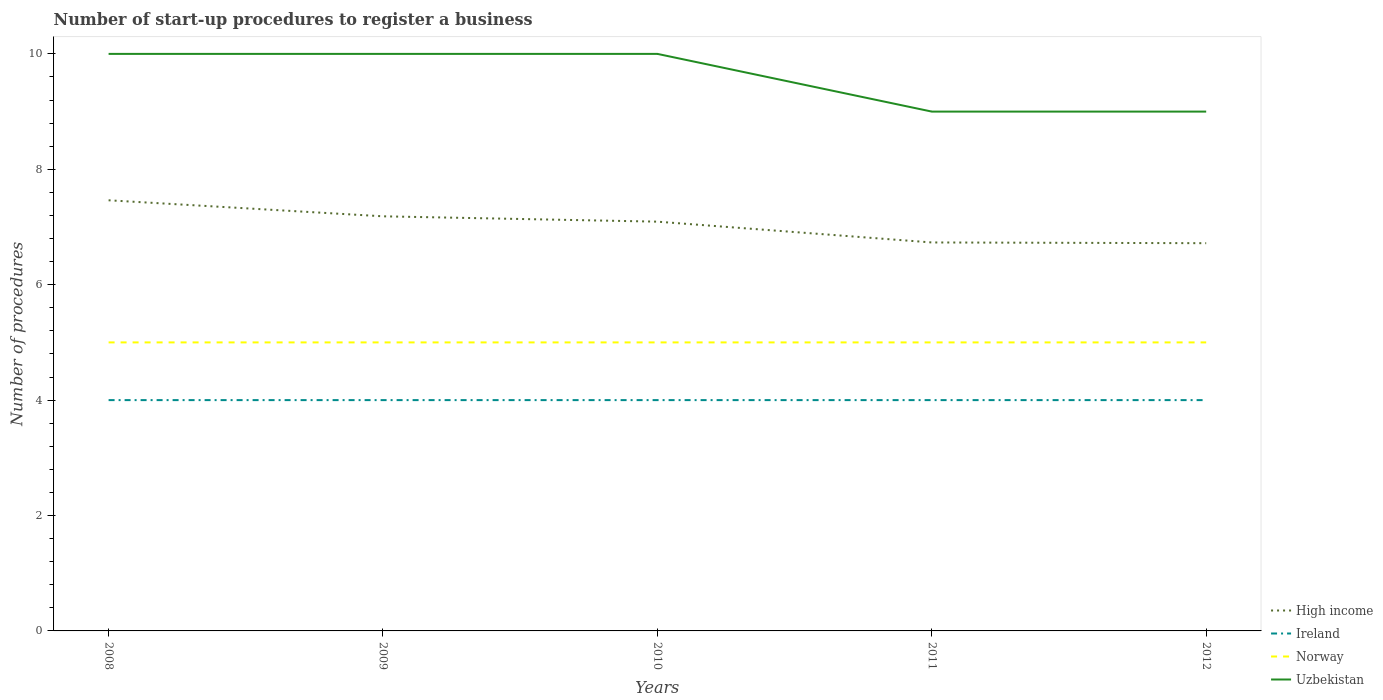How many different coloured lines are there?
Provide a succinct answer. 4. Is the number of lines equal to the number of legend labels?
Give a very brief answer. Yes. Across all years, what is the maximum number of procedures required to register a business in Uzbekistan?
Provide a succinct answer. 9. What is the total number of procedures required to register a business in Uzbekistan in the graph?
Offer a terse response. 0. What is the difference between the highest and the second highest number of procedures required to register a business in Norway?
Your answer should be very brief. 0. What is the difference between the highest and the lowest number of procedures required to register a business in High income?
Offer a very short reply. 3. Is the number of procedures required to register a business in Norway strictly greater than the number of procedures required to register a business in Uzbekistan over the years?
Provide a short and direct response. Yes. Where does the legend appear in the graph?
Ensure brevity in your answer.  Bottom right. What is the title of the graph?
Offer a very short reply. Number of start-up procedures to register a business. What is the label or title of the X-axis?
Provide a succinct answer. Years. What is the label or title of the Y-axis?
Offer a terse response. Number of procedures. What is the Number of procedures of High income in 2008?
Give a very brief answer. 7.46. What is the Number of procedures in Ireland in 2008?
Your answer should be compact. 4. What is the Number of procedures of High income in 2009?
Provide a succinct answer. 7.19. What is the Number of procedures of Ireland in 2009?
Your answer should be very brief. 4. What is the Number of procedures of Norway in 2009?
Your response must be concise. 5. What is the Number of procedures in High income in 2010?
Ensure brevity in your answer.  7.09. What is the Number of procedures of Ireland in 2010?
Your answer should be very brief. 4. What is the Number of procedures in Uzbekistan in 2010?
Your answer should be very brief. 10. What is the Number of procedures of High income in 2011?
Offer a terse response. 6.73. What is the Number of procedures in Uzbekistan in 2011?
Offer a very short reply. 9. What is the Number of procedures of High income in 2012?
Offer a very short reply. 6.72. What is the Number of procedures of Ireland in 2012?
Your response must be concise. 4. Across all years, what is the maximum Number of procedures of High income?
Ensure brevity in your answer.  7.46. Across all years, what is the maximum Number of procedures in Uzbekistan?
Ensure brevity in your answer.  10. Across all years, what is the minimum Number of procedures in High income?
Make the answer very short. 6.72. Across all years, what is the minimum Number of procedures in Ireland?
Give a very brief answer. 4. Across all years, what is the minimum Number of procedures of Norway?
Provide a short and direct response. 5. What is the total Number of procedures of High income in the graph?
Your answer should be compact. 35.19. What is the total Number of procedures of Ireland in the graph?
Make the answer very short. 20. What is the difference between the Number of procedures of High income in 2008 and that in 2009?
Offer a terse response. 0.28. What is the difference between the Number of procedures of Ireland in 2008 and that in 2009?
Provide a succinct answer. 0. What is the difference between the Number of procedures in Norway in 2008 and that in 2009?
Give a very brief answer. 0. What is the difference between the Number of procedures in High income in 2008 and that in 2010?
Give a very brief answer. 0.37. What is the difference between the Number of procedures in Uzbekistan in 2008 and that in 2010?
Make the answer very short. 0. What is the difference between the Number of procedures in High income in 2008 and that in 2011?
Your answer should be very brief. 0.73. What is the difference between the Number of procedures in Norway in 2008 and that in 2011?
Keep it short and to the point. 0. What is the difference between the Number of procedures in Uzbekistan in 2008 and that in 2011?
Offer a very short reply. 1. What is the difference between the Number of procedures in High income in 2008 and that in 2012?
Offer a very short reply. 0.74. What is the difference between the Number of procedures of Ireland in 2008 and that in 2012?
Your answer should be compact. 0. What is the difference between the Number of procedures of High income in 2009 and that in 2010?
Ensure brevity in your answer.  0.09. What is the difference between the Number of procedures of Uzbekistan in 2009 and that in 2010?
Offer a terse response. 0. What is the difference between the Number of procedures of High income in 2009 and that in 2011?
Ensure brevity in your answer.  0.45. What is the difference between the Number of procedures in Ireland in 2009 and that in 2011?
Provide a short and direct response. 0. What is the difference between the Number of procedures in High income in 2009 and that in 2012?
Provide a short and direct response. 0.47. What is the difference between the Number of procedures in Ireland in 2009 and that in 2012?
Keep it short and to the point. 0. What is the difference between the Number of procedures in Norway in 2009 and that in 2012?
Keep it short and to the point. 0. What is the difference between the Number of procedures of Uzbekistan in 2009 and that in 2012?
Offer a terse response. 1. What is the difference between the Number of procedures in High income in 2010 and that in 2011?
Ensure brevity in your answer.  0.36. What is the difference between the Number of procedures in Ireland in 2010 and that in 2011?
Keep it short and to the point. 0. What is the difference between the Number of procedures in Norway in 2010 and that in 2011?
Offer a very short reply. 0. What is the difference between the Number of procedures in Uzbekistan in 2010 and that in 2011?
Your answer should be very brief. 1. What is the difference between the Number of procedures in High income in 2010 and that in 2012?
Offer a terse response. 0.37. What is the difference between the Number of procedures in Ireland in 2010 and that in 2012?
Give a very brief answer. 0. What is the difference between the Number of procedures in Norway in 2010 and that in 2012?
Provide a short and direct response. 0. What is the difference between the Number of procedures of High income in 2011 and that in 2012?
Your answer should be compact. 0.01. What is the difference between the Number of procedures in Ireland in 2011 and that in 2012?
Give a very brief answer. 0. What is the difference between the Number of procedures of Norway in 2011 and that in 2012?
Your answer should be very brief. 0. What is the difference between the Number of procedures of High income in 2008 and the Number of procedures of Ireland in 2009?
Offer a very short reply. 3.46. What is the difference between the Number of procedures in High income in 2008 and the Number of procedures in Norway in 2009?
Keep it short and to the point. 2.46. What is the difference between the Number of procedures in High income in 2008 and the Number of procedures in Uzbekistan in 2009?
Make the answer very short. -2.54. What is the difference between the Number of procedures of Ireland in 2008 and the Number of procedures of Uzbekistan in 2009?
Offer a very short reply. -6. What is the difference between the Number of procedures in Norway in 2008 and the Number of procedures in Uzbekistan in 2009?
Your response must be concise. -5. What is the difference between the Number of procedures of High income in 2008 and the Number of procedures of Ireland in 2010?
Provide a succinct answer. 3.46. What is the difference between the Number of procedures in High income in 2008 and the Number of procedures in Norway in 2010?
Your answer should be compact. 2.46. What is the difference between the Number of procedures in High income in 2008 and the Number of procedures in Uzbekistan in 2010?
Make the answer very short. -2.54. What is the difference between the Number of procedures in High income in 2008 and the Number of procedures in Ireland in 2011?
Give a very brief answer. 3.46. What is the difference between the Number of procedures in High income in 2008 and the Number of procedures in Norway in 2011?
Provide a short and direct response. 2.46. What is the difference between the Number of procedures in High income in 2008 and the Number of procedures in Uzbekistan in 2011?
Provide a short and direct response. -1.54. What is the difference between the Number of procedures in Ireland in 2008 and the Number of procedures in Uzbekistan in 2011?
Provide a short and direct response. -5. What is the difference between the Number of procedures of High income in 2008 and the Number of procedures of Ireland in 2012?
Your response must be concise. 3.46. What is the difference between the Number of procedures in High income in 2008 and the Number of procedures in Norway in 2012?
Your answer should be compact. 2.46. What is the difference between the Number of procedures of High income in 2008 and the Number of procedures of Uzbekistan in 2012?
Provide a short and direct response. -1.54. What is the difference between the Number of procedures of Ireland in 2008 and the Number of procedures of Uzbekistan in 2012?
Offer a very short reply. -5. What is the difference between the Number of procedures of Norway in 2008 and the Number of procedures of Uzbekistan in 2012?
Your answer should be very brief. -4. What is the difference between the Number of procedures of High income in 2009 and the Number of procedures of Ireland in 2010?
Your answer should be very brief. 3.19. What is the difference between the Number of procedures of High income in 2009 and the Number of procedures of Norway in 2010?
Make the answer very short. 2.19. What is the difference between the Number of procedures in High income in 2009 and the Number of procedures in Uzbekistan in 2010?
Make the answer very short. -2.81. What is the difference between the Number of procedures of Ireland in 2009 and the Number of procedures of Norway in 2010?
Your response must be concise. -1. What is the difference between the Number of procedures in High income in 2009 and the Number of procedures in Ireland in 2011?
Ensure brevity in your answer.  3.19. What is the difference between the Number of procedures of High income in 2009 and the Number of procedures of Norway in 2011?
Provide a succinct answer. 2.19. What is the difference between the Number of procedures of High income in 2009 and the Number of procedures of Uzbekistan in 2011?
Your answer should be compact. -1.81. What is the difference between the Number of procedures in High income in 2009 and the Number of procedures in Ireland in 2012?
Give a very brief answer. 3.19. What is the difference between the Number of procedures of High income in 2009 and the Number of procedures of Norway in 2012?
Your answer should be compact. 2.19. What is the difference between the Number of procedures of High income in 2009 and the Number of procedures of Uzbekistan in 2012?
Provide a short and direct response. -1.81. What is the difference between the Number of procedures of Ireland in 2009 and the Number of procedures of Uzbekistan in 2012?
Provide a succinct answer. -5. What is the difference between the Number of procedures in Norway in 2009 and the Number of procedures in Uzbekistan in 2012?
Offer a very short reply. -4. What is the difference between the Number of procedures of High income in 2010 and the Number of procedures of Ireland in 2011?
Your response must be concise. 3.09. What is the difference between the Number of procedures in High income in 2010 and the Number of procedures in Norway in 2011?
Your answer should be compact. 2.09. What is the difference between the Number of procedures in High income in 2010 and the Number of procedures in Uzbekistan in 2011?
Your answer should be compact. -1.91. What is the difference between the Number of procedures of Norway in 2010 and the Number of procedures of Uzbekistan in 2011?
Ensure brevity in your answer.  -4. What is the difference between the Number of procedures in High income in 2010 and the Number of procedures in Ireland in 2012?
Provide a short and direct response. 3.09. What is the difference between the Number of procedures of High income in 2010 and the Number of procedures of Norway in 2012?
Offer a very short reply. 2.09. What is the difference between the Number of procedures in High income in 2010 and the Number of procedures in Uzbekistan in 2012?
Offer a terse response. -1.91. What is the difference between the Number of procedures in Ireland in 2010 and the Number of procedures in Uzbekistan in 2012?
Your answer should be compact. -5. What is the difference between the Number of procedures in Norway in 2010 and the Number of procedures in Uzbekistan in 2012?
Keep it short and to the point. -4. What is the difference between the Number of procedures in High income in 2011 and the Number of procedures in Ireland in 2012?
Your answer should be compact. 2.73. What is the difference between the Number of procedures of High income in 2011 and the Number of procedures of Norway in 2012?
Provide a short and direct response. 1.73. What is the difference between the Number of procedures of High income in 2011 and the Number of procedures of Uzbekistan in 2012?
Offer a very short reply. -2.27. What is the difference between the Number of procedures in Norway in 2011 and the Number of procedures in Uzbekistan in 2012?
Offer a terse response. -4. What is the average Number of procedures in High income per year?
Provide a succinct answer. 7.04. What is the average Number of procedures of Ireland per year?
Your answer should be compact. 4. What is the average Number of procedures of Norway per year?
Give a very brief answer. 5. In the year 2008, what is the difference between the Number of procedures of High income and Number of procedures of Ireland?
Your answer should be compact. 3.46. In the year 2008, what is the difference between the Number of procedures in High income and Number of procedures in Norway?
Your answer should be very brief. 2.46. In the year 2008, what is the difference between the Number of procedures of High income and Number of procedures of Uzbekistan?
Your answer should be compact. -2.54. In the year 2008, what is the difference between the Number of procedures of Ireland and Number of procedures of Norway?
Keep it short and to the point. -1. In the year 2008, what is the difference between the Number of procedures of Norway and Number of procedures of Uzbekistan?
Your answer should be compact. -5. In the year 2009, what is the difference between the Number of procedures in High income and Number of procedures in Ireland?
Provide a short and direct response. 3.19. In the year 2009, what is the difference between the Number of procedures of High income and Number of procedures of Norway?
Your response must be concise. 2.19. In the year 2009, what is the difference between the Number of procedures of High income and Number of procedures of Uzbekistan?
Your response must be concise. -2.81. In the year 2009, what is the difference between the Number of procedures in Ireland and Number of procedures in Norway?
Provide a succinct answer. -1. In the year 2010, what is the difference between the Number of procedures in High income and Number of procedures in Ireland?
Offer a very short reply. 3.09. In the year 2010, what is the difference between the Number of procedures in High income and Number of procedures in Norway?
Ensure brevity in your answer.  2.09. In the year 2010, what is the difference between the Number of procedures of High income and Number of procedures of Uzbekistan?
Your answer should be very brief. -2.91. In the year 2010, what is the difference between the Number of procedures in Ireland and Number of procedures in Norway?
Keep it short and to the point. -1. In the year 2010, what is the difference between the Number of procedures in Ireland and Number of procedures in Uzbekistan?
Make the answer very short. -6. In the year 2010, what is the difference between the Number of procedures of Norway and Number of procedures of Uzbekistan?
Your answer should be very brief. -5. In the year 2011, what is the difference between the Number of procedures of High income and Number of procedures of Ireland?
Make the answer very short. 2.73. In the year 2011, what is the difference between the Number of procedures in High income and Number of procedures in Norway?
Provide a short and direct response. 1.73. In the year 2011, what is the difference between the Number of procedures in High income and Number of procedures in Uzbekistan?
Keep it short and to the point. -2.27. In the year 2011, what is the difference between the Number of procedures in Ireland and Number of procedures in Norway?
Offer a terse response. -1. In the year 2011, what is the difference between the Number of procedures of Ireland and Number of procedures of Uzbekistan?
Offer a very short reply. -5. In the year 2011, what is the difference between the Number of procedures of Norway and Number of procedures of Uzbekistan?
Ensure brevity in your answer.  -4. In the year 2012, what is the difference between the Number of procedures of High income and Number of procedures of Ireland?
Keep it short and to the point. 2.72. In the year 2012, what is the difference between the Number of procedures in High income and Number of procedures in Norway?
Your answer should be very brief. 1.72. In the year 2012, what is the difference between the Number of procedures of High income and Number of procedures of Uzbekistan?
Make the answer very short. -2.28. In the year 2012, what is the difference between the Number of procedures of Norway and Number of procedures of Uzbekistan?
Make the answer very short. -4. What is the ratio of the Number of procedures of High income in 2008 to that in 2009?
Keep it short and to the point. 1.04. What is the ratio of the Number of procedures in Norway in 2008 to that in 2009?
Ensure brevity in your answer.  1. What is the ratio of the Number of procedures of Uzbekistan in 2008 to that in 2009?
Make the answer very short. 1. What is the ratio of the Number of procedures of High income in 2008 to that in 2010?
Provide a succinct answer. 1.05. What is the ratio of the Number of procedures in Norway in 2008 to that in 2010?
Your response must be concise. 1. What is the ratio of the Number of procedures of High income in 2008 to that in 2011?
Provide a succinct answer. 1.11. What is the ratio of the Number of procedures of Ireland in 2008 to that in 2011?
Provide a short and direct response. 1. What is the ratio of the Number of procedures in Norway in 2008 to that in 2011?
Offer a terse response. 1. What is the ratio of the Number of procedures in High income in 2008 to that in 2012?
Provide a succinct answer. 1.11. What is the ratio of the Number of procedures in High income in 2009 to that in 2010?
Make the answer very short. 1.01. What is the ratio of the Number of procedures in Ireland in 2009 to that in 2010?
Your response must be concise. 1. What is the ratio of the Number of procedures in Norway in 2009 to that in 2010?
Make the answer very short. 1. What is the ratio of the Number of procedures in High income in 2009 to that in 2011?
Your answer should be compact. 1.07. What is the ratio of the Number of procedures of Ireland in 2009 to that in 2011?
Provide a short and direct response. 1. What is the ratio of the Number of procedures in Uzbekistan in 2009 to that in 2011?
Your answer should be compact. 1.11. What is the ratio of the Number of procedures of High income in 2009 to that in 2012?
Make the answer very short. 1.07. What is the ratio of the Number of procedures of Norway in 2009 to that in 2012?
Keep it short and to the point. 1. What is the ratio of the Number of procedures of Uzbekistan in 2009 to that in 2012?
Ensure brevity in your answer.  1.11. What is the ratio of the Number of procedures of High income in 2010 to that in 2011?
Provide a succinct answer. 1.05. What is the ratio of the Number of procedures in Ireland in 2010 to that in 2011?
Keep it short and to the point. 1. What is the ratio of the Number of procedures of Norway in 2010 to that in 2011?
Provide a succinct answer. 1. What is the ratio of the Number of procedures in High income in 2010 to that in 2012?
Give a very brief answer. 1.06. What is the ratio of the Number of procedures in Ireland in 2010 to that in 2012?
Offer a very short reply. 1. What is the ratio of the Number of procedures in Ireland in 2011 to that in 2012?
Your answer should be compact. 1. What is the ratio of the Number of procedures in Norway in 2011 to that in 2012?
Provide a succinct answer. 1. What is the difference between the highest and the second highest Number of procedures of High income?
Provide a succinct answer. 0.28. What is the difference between the highest and the second highest Number of procedures of Ireland?
Keep it short and to the point. 0. What is the difference between the highest and the second highest Number of procedures in Uzbekistan?
Keep it short and to the point. 0. What is the difference between the highest and the lowest Number of procedures of High income?
Your response must be concise. 0.74. What is the difference between the highest and the lowest Number of procedures in Ireland?
Your response must be concise. 0. What is the difference between the highest and the lowest Number of procedures in Norway?
Provide a short and direct response. 0. What is the difference between the highest and the lowest Number of procedures of Uzbekistan?
Your answer should be very brief. 1. 